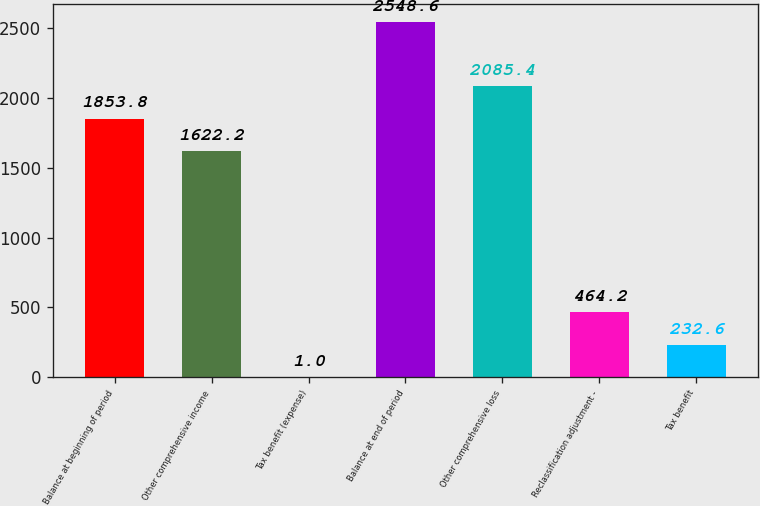<chart> <loc_0><loc_0><loc_500><loc_500><bar_chart><fcel>Balance at beginning of period<fcel>Other comprehensive income<fcel>Tax benefit (expense)<fcel>Balance at end of period<fcel>Other comprehensive loss<fcel>Reclassification adjustment -<fcel>Tax benefit<nl><fcel>1853.8<fcel>1622.2<fcel>1<fcel>2548.6<fcel>2085.4<fcel>464.2<fcel>232.6<nl></chart> 